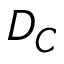Convert formula to latex. <formula><loc_0><loc_0><loc_500><loc_500>D _ { C }</formula> 